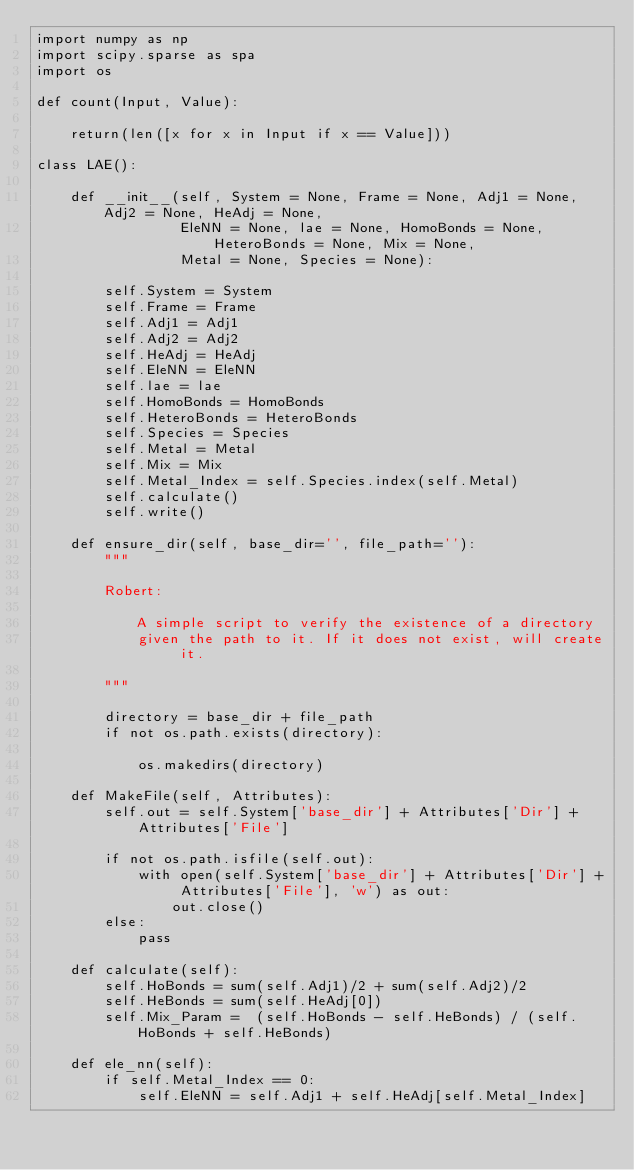Convert code to text. <code><loc_0><loc_0><loc_500><loc_500><_Python_>import numpy as np
import scipy.sparse as spa
import os

def count(Input, Value):
    
    return(len([x for x in Input if x == Value]))

class LAE():

    def __init__(self, System = None, Frame = None, Adj1 = None, Adj2 = None, HeAdj = None, 
                 EleNN = None, lae = None, HomoBonds = None, HeteroBonds = None, Mix = None,
                 Metal = None, Species = None):
        
        self.System = System
        self.Frame = Frame
        self.Adj1 = Adj1
        self.Adj2 = Adj2
        self.HeAdj = HeAdj
        self.EleNN = EleNN
        self.lae = lae
        self.HomoBonds = HomoBonds
        self.HeteroBonds = HeteroBonds
        self.Species = Species        
        self.Metal = Metal
        self.Mix = Mix
        self.Metal_Index = self.Species.index(self.Metal)
        self.calculate()
        self.write()
        
    def ensure_dir(self, base_dir='', file_path=''):
        """

        Robert:

            A simple script to verify the existence of a directory
            given the path to it. If it does not exist, will create it.

        """

        directory = base_dir + file_path
        if not os.path.exists(directory):

            os.makedirs(directory)

    def MakeFile(self, Attributes):
        self.out = self.System['base_dir'] + Attributes['Dir'] + Attributes['File']

        if not os.path.isfile(self.out):
            with open(self.System['base_dir'] + Attributes['Dir'] + Attributes['File'], 'w') as out:
                out.close()
        else:
            pass
        
    def calculate(self):
        self.HoBonds = sum(self.Adj1)/2 + sum(self.Adj2)/2
        self.HeBonds = sum(self.HeAdj[0])
        self.Mix_Param =  (self.HoBonds - self.HeBonds) / (self.HoBonds + self.HeBonds)
    
    def ele_nn(self):
        if self.Metal_Index == 0:
            self.EleNN = self.Adj1 + self.HeAdj[self.Metal_Index]</code> 